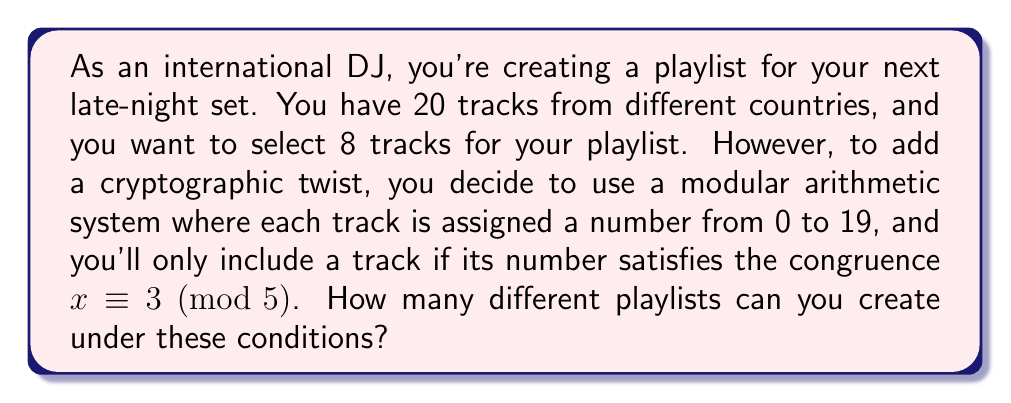Can you answer this question? Let's approach this step-by-step:

1) First, we need to determine which track numbers satisfy the congruence $x \equiv 3 \pmod{5}$.

2) The numbers that satisfy this are: 3, 8, 13, 18. These are the numbers that leave a remainder of 3 when divided by 5.

3) Out of our 20 tracks, only 4 tracks (with these numbers) are eligible for the playlist.

4) Now, our problem reduces to: How many ways can we choose 8 tracks out of these 4 eligible tracks, with repetition allowed?

5) This is a classic combination with repetition problem. The formula for this is:

   $$\binom{n+r-1}{r} = \binom{n+r-1}{n-1}$$

   where $n$ is the number of types of objects (in our case, 4 eligible tracks) and $r$ is the number of objects we're choosing (8 tracks for the playlist).

6) Plugging in our values:

   $$\binom{4+8-1}{8} = \binom{11}{8} = \binom{11}{3}$$

7) We can calculate this:

   $$\binom{11}{3} = \frac{11!}{3!(11-3)!} = \frac{11!}{3!8!} = 165$$

Therefore, there are 165 different possible playlists.
Answer: 165 